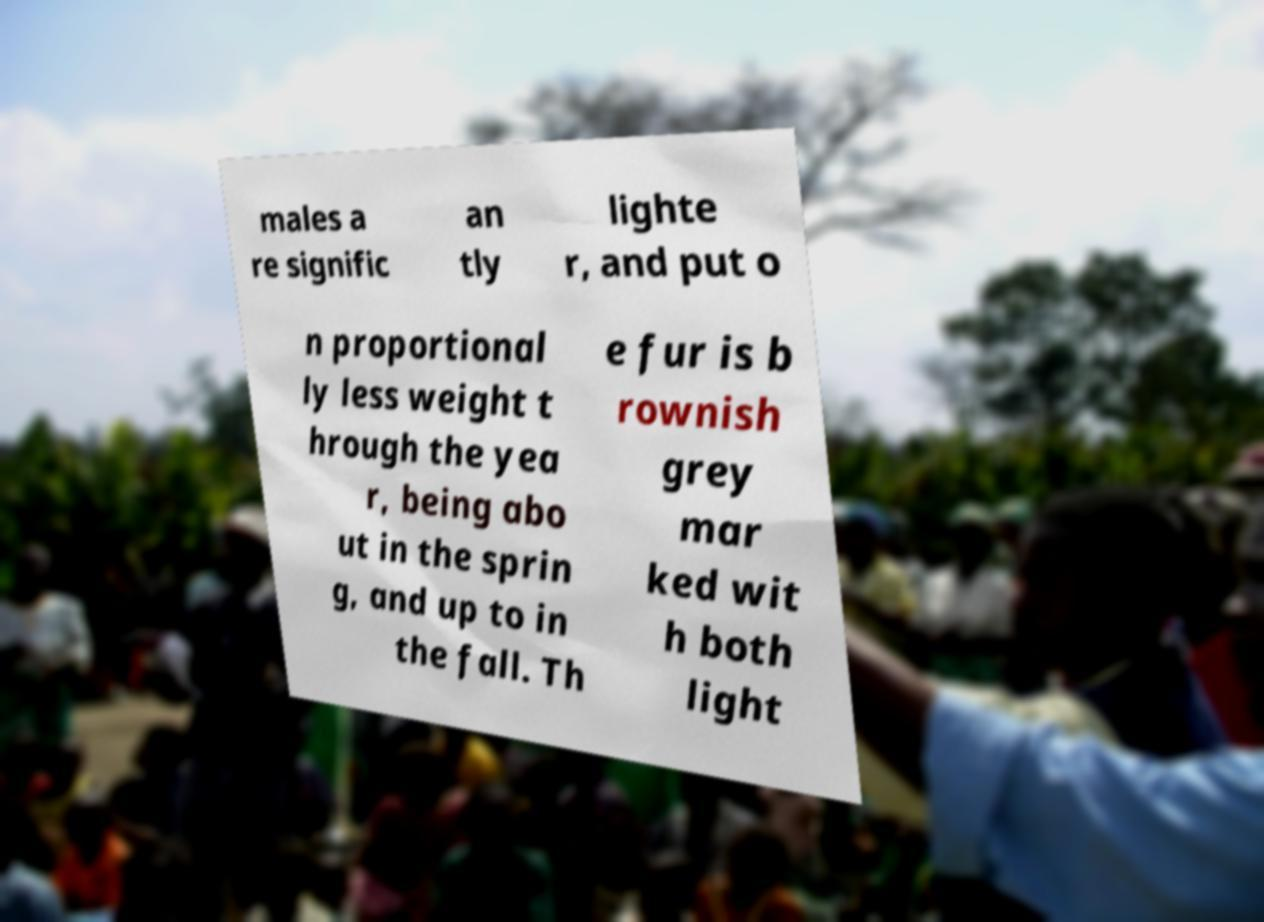I need the written content from this picture converted into text. Can you do that? males a re signific an tly lighte r, and put o n proportional ly less weight t hrough the yea r, being abo ut in the sprin g, and up to in the fall. Th e fur is b rownish grey mar ked wit h both light 